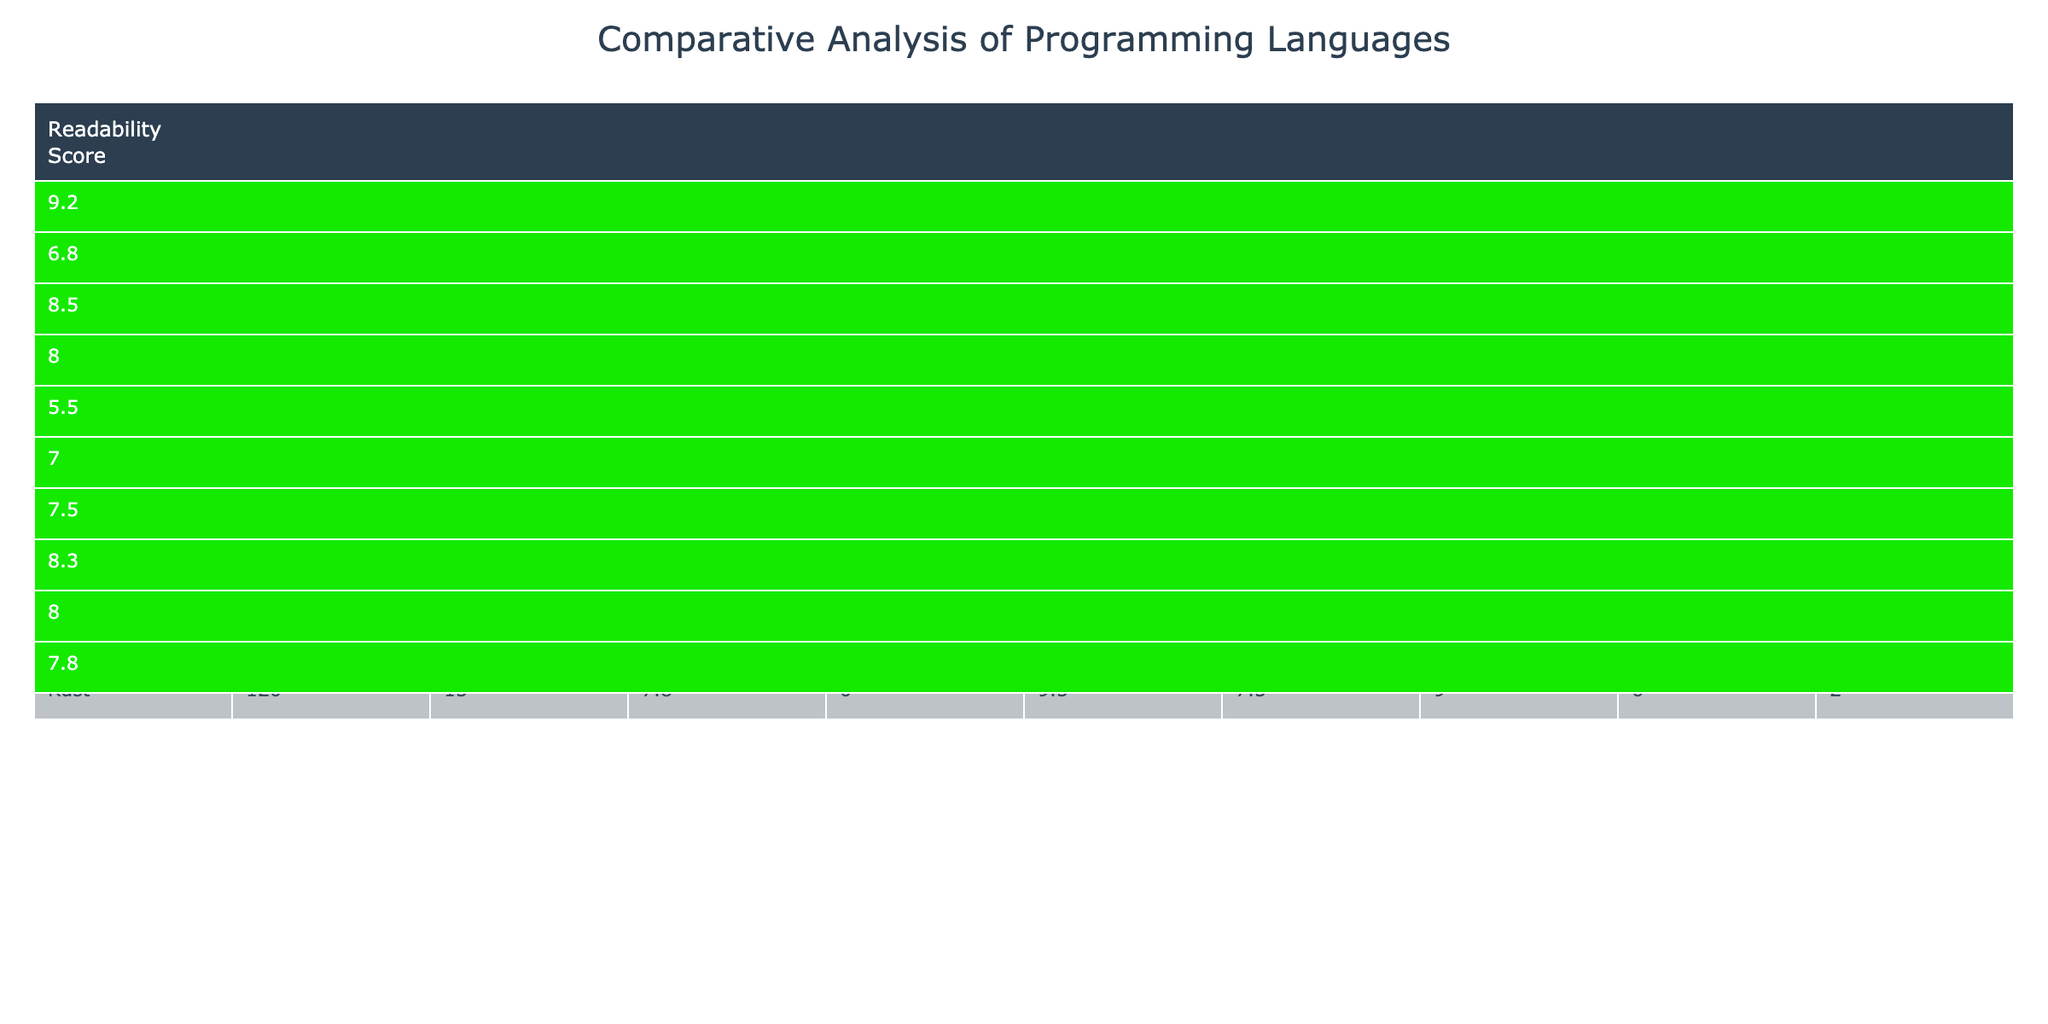What is the Readability Score for Swift? The table shows that the Readability Score for Swift is 9.2, which can be directly found under the "Readability Score" column for Swift.
Answer: 9.2 How many lines of code does Java use? The table indicates that Java uses 150 lines of code, as found in the "Lines of Code" column corresponding to Java.
Answer: 150 Which language has the highest Syntax Clarity Rating? Looking at the "Syntax Clarity Rating" column, Swift has the highest rating of 9.0 compared to other languages listed.
Answer: Swift Is it true that Python uses anonymous classes? The table indicates that Python has 0 anonymous classes used, so it is false to say that it uses anonymous classes.
Answer: False Which language has the lowest community support score? By reviewing the "Community Support" column, Ruby has a score of 2, which is the lowest amongst all languages.
Answer: Ruby Calculate the average Readability Score of the languages listed. To find the average, add all the Readability Scores (9.2 + 6.8 + 8.5 + 8.0 + 5.5 + 7.0 + 7.5 + 8.3 + 8.0 + 7.8) = 78.6, then divide by the number of languages (10). The average is 78.6 / 10 = 7.86.
Answer: 7.86 How does the Type Safety Score of Kotlin compare to that of C#? Kotlin has a Type Safety Score of 9.0 while C# has a score of 8.5. Hence, Kotlin has a higher Type Safety Score than C#.
Answer: Kotlin is higher What is the difference in Lines of Code between Objective-C and Go? Objective-C uses 180 lines of code and Go uses 105. Therefore, the difference is 180 - 105 = 75 lines.
Answer: 75 Which languages do not use anonymous classes? By checking the "Anonymous Classes Used" column, Swift, Python, Ruby, Go, and Rust show 0, indicating they do not use anonymous classes.
Answer: Swift, Python, Ruby, Go, Rust If you were to rank languages by Readability Score from highest to lowest, which would be the first three? The top three languages by Readability Score are Swift (9.2), Python (8.5), and Kotlin (8.0) when sorted from highest to lowest.
Answer: Swift, Python, Kotlin 